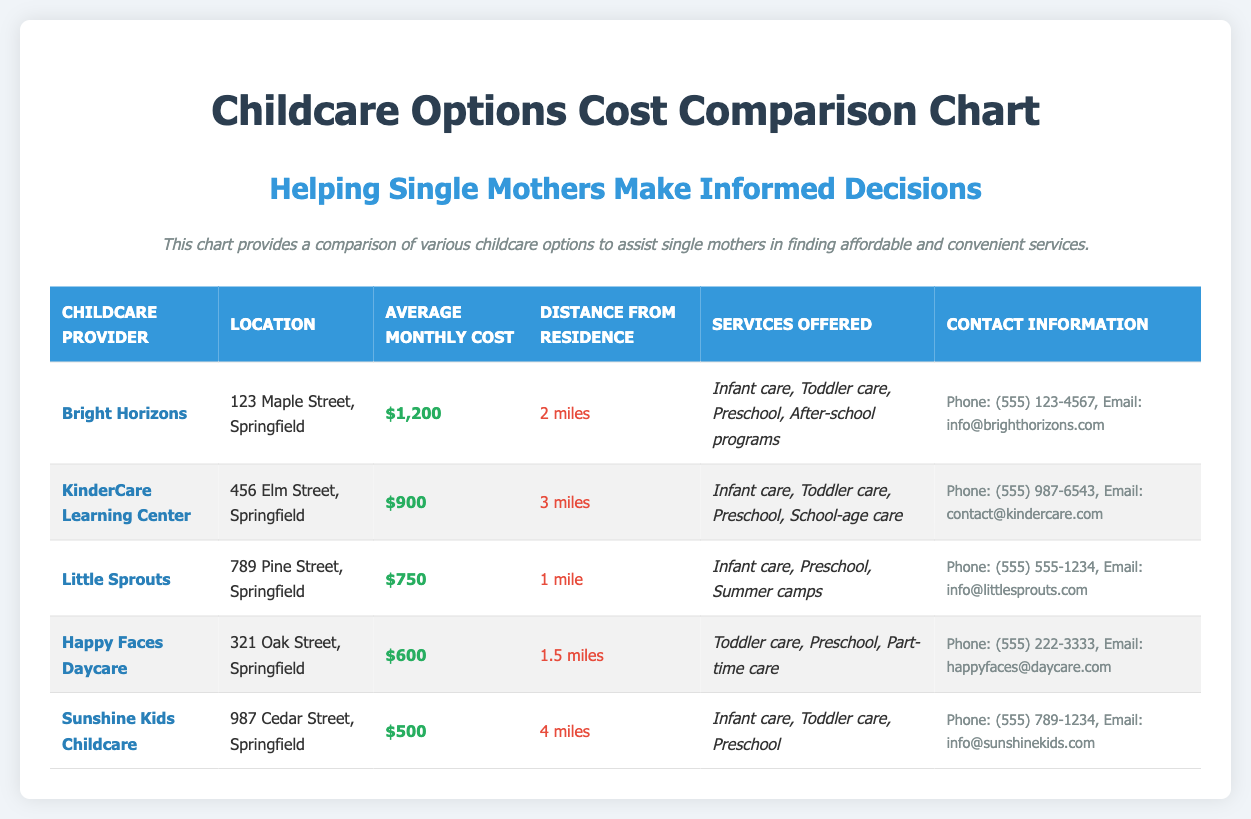What is the average monthly cost of Bright Horizons? The average monthly cost is stated directly in the chart for Bright Horizons, which is $1,200.
Answer: $1,200 What services are offered by Happy Faces Daycare? The services offered by Happy Faces Daycare are listed in the document, which include Toddler care, Preschool, and Part-time care.
Answer: Toddler care, Preschool, Part-time care How far is Little Sprouts from residence? The distance from residence for Little Sprouts is specified in the chart as 1 mile.
Answer: 1 mile Which childcare provider has the lowest cost? By comparing the average monthly costs in the chart, Sunshine Kids Childcare has the lowest cost at $500.
Answer: Sunshine Kids Childcare What is the contact phone number for KinderCare Learning Center? The contact information includes the phone number for KinderCare Learning Center, which is (555) 987-6543.
Answer: (555) 987-6543 How many miles away is Sunshine Kids Childcare? The distance for Sunshine Kids Childcare is mentioned as 4 miles from residence.
Answer: 4 miles Which provider offers summer camps? The services section indicates that Little Sprouts offers summer camps.
Answer: Little Sprouts What is the average monthly cost range for all providers listed? By reviewing the document, the costs range from $500 to $1,200 among all providers.
Answer: $500 to $1,200 